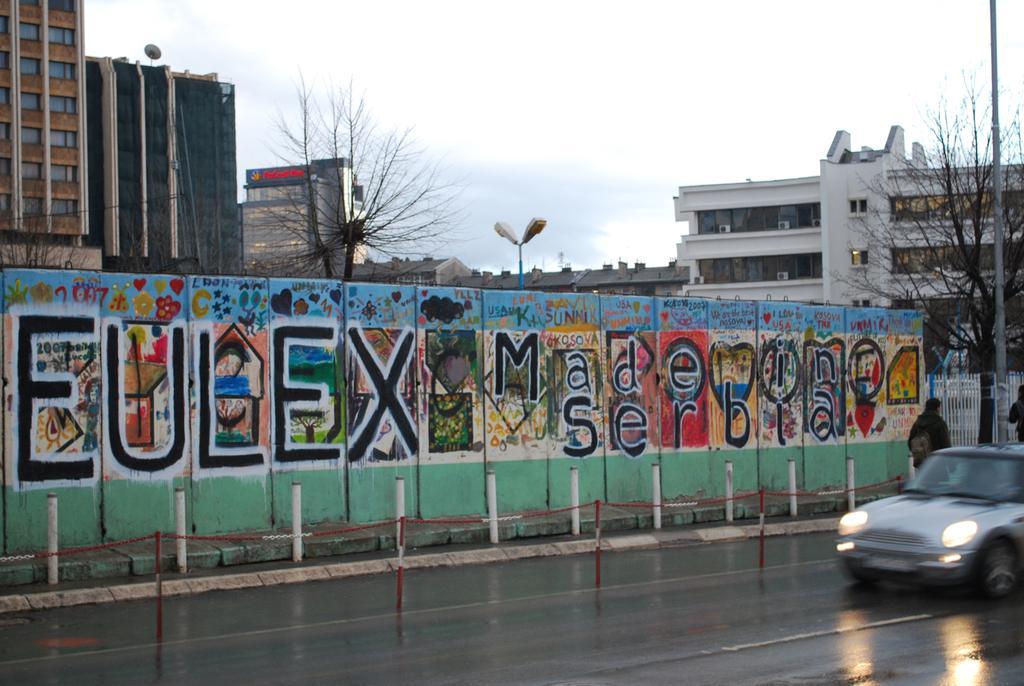Describe this image in one or two sentences. In this picture there is road towards the right and wall towards the left. Towards the left corner there are two persons, pole, trees and a car. To the wall there are some text and pictures are printed. Towards the top left there are buildings. In the top there is a blue sky. 